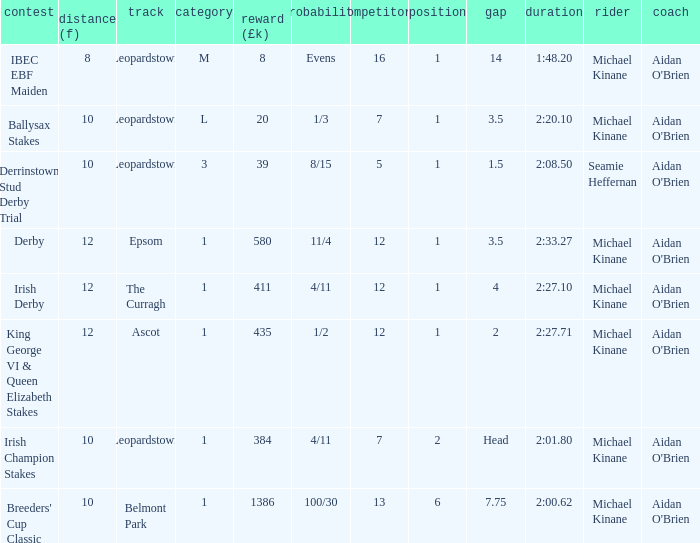Which Race has a Runners of 7 and Odds of 1/3? Ballysax Stakes. 